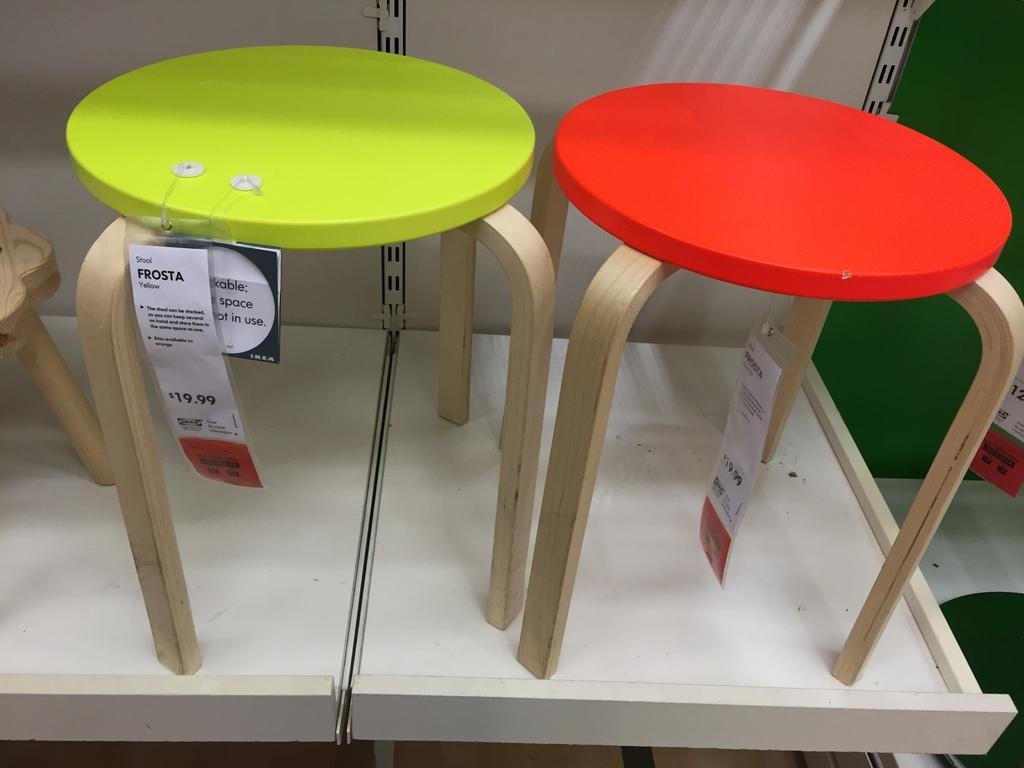Describe this image in one or two sentences. This is a zoomed in picture. In the foreground there is a white color object seems to be the shelf and we can see the green color stool and a red color stool placed on the shelf. In the background there is a green color wall and we can see the tags hanging on the stools. 